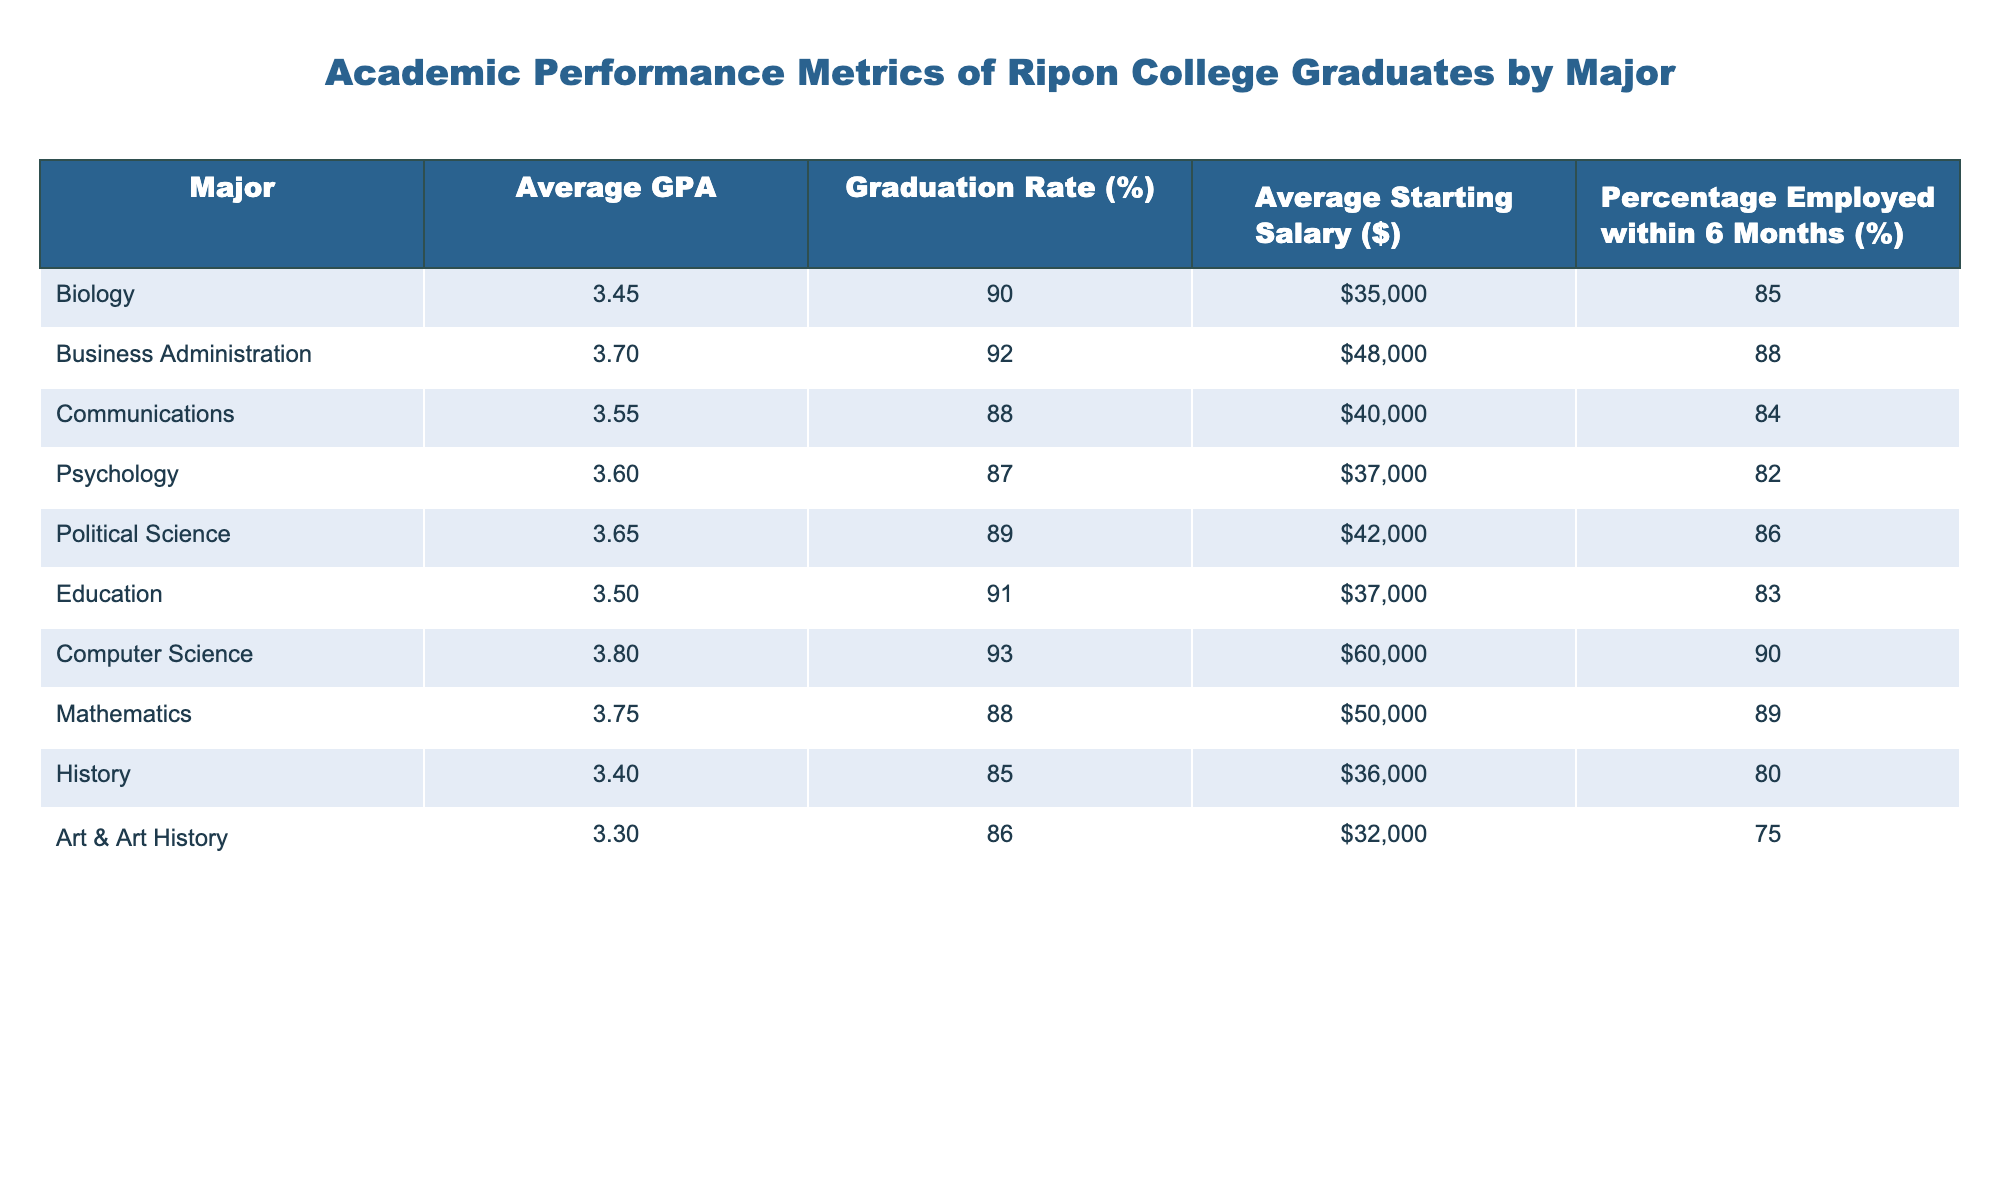What is the average GPA for graduates in Business Administration? The table lists the Average GPA for each major. For Business Administration, the value is directly noted as 3.70.
Answer: 3.70 Which major has the highest graduation rate? Looking at the Graduation Rate (%) column, the Business Administration major has the highest percentage listed as 92%.
Answer: Business Administration What is the average starting salary for graduates majoring in Computer Science? The Average Starting Salary column shows that graduates in Computer Science have an average starting salary of $60,000.
Answer: $60,000 What is the percentage of Psychology graduates who are employed within 6 months? According to the Percentage Employed within 6 Months (%) column, 82% of Psychology graduates are employed within 6 months.
Answer: 82% What is the difference in average GPA between Computer Science and History graduates? To find the difference, subtract the average GPA of History (3.40) from the average GPA of Computer Science (3.80): 3.80 - 3.40 = 0.40.
Answer: 0.40 Is the average starting salary for Education graduates higher than that of Biology graduates? The Average Starting Salary for Education graduates is $37,000, while for Biology graduates it is $35,000. Therefore, Education graduates have a higher starting salary.
Answer: Yes Which two majors have the closest average GPA? To find this, we can compare the GPAs: Education (3.50) and Psychology (3.60) have a difference of 0.10, which is the smallest among all pairs.
Answer: Education and Psychology If we were to average the starting salaries for History and Art & Art History graduates, what would that be? The average starting salary for History graduates is $36,000 and for Art & Art History is $32,000. The average is calculated as ($36,000 + $32,000) / 2 = $34,000.
Answer: $34,000 Are Computer Science graduates more likely to be employed within 6 months compared to Psychology graduates? The employment rate for Computer Science graduates is 90%, while for Psychology graduates it is 82%. Hence, Computer Science graduates are more likely to be employed within 6 months.
Answer: Yes What is the overall average starting salary for the five majors with the lowest average GPAs? The five majors with the lowest GPAs are Art & Art History (32,000), History (36,000), Psychology (37,000), Biology (35,000), and Communications (40,000). Their average starting salary is calculated as: ($32,000 + $36,000 + $37,000 + $35,000 + $40,000) / 5 = $36,000.
Answer: $36,000 